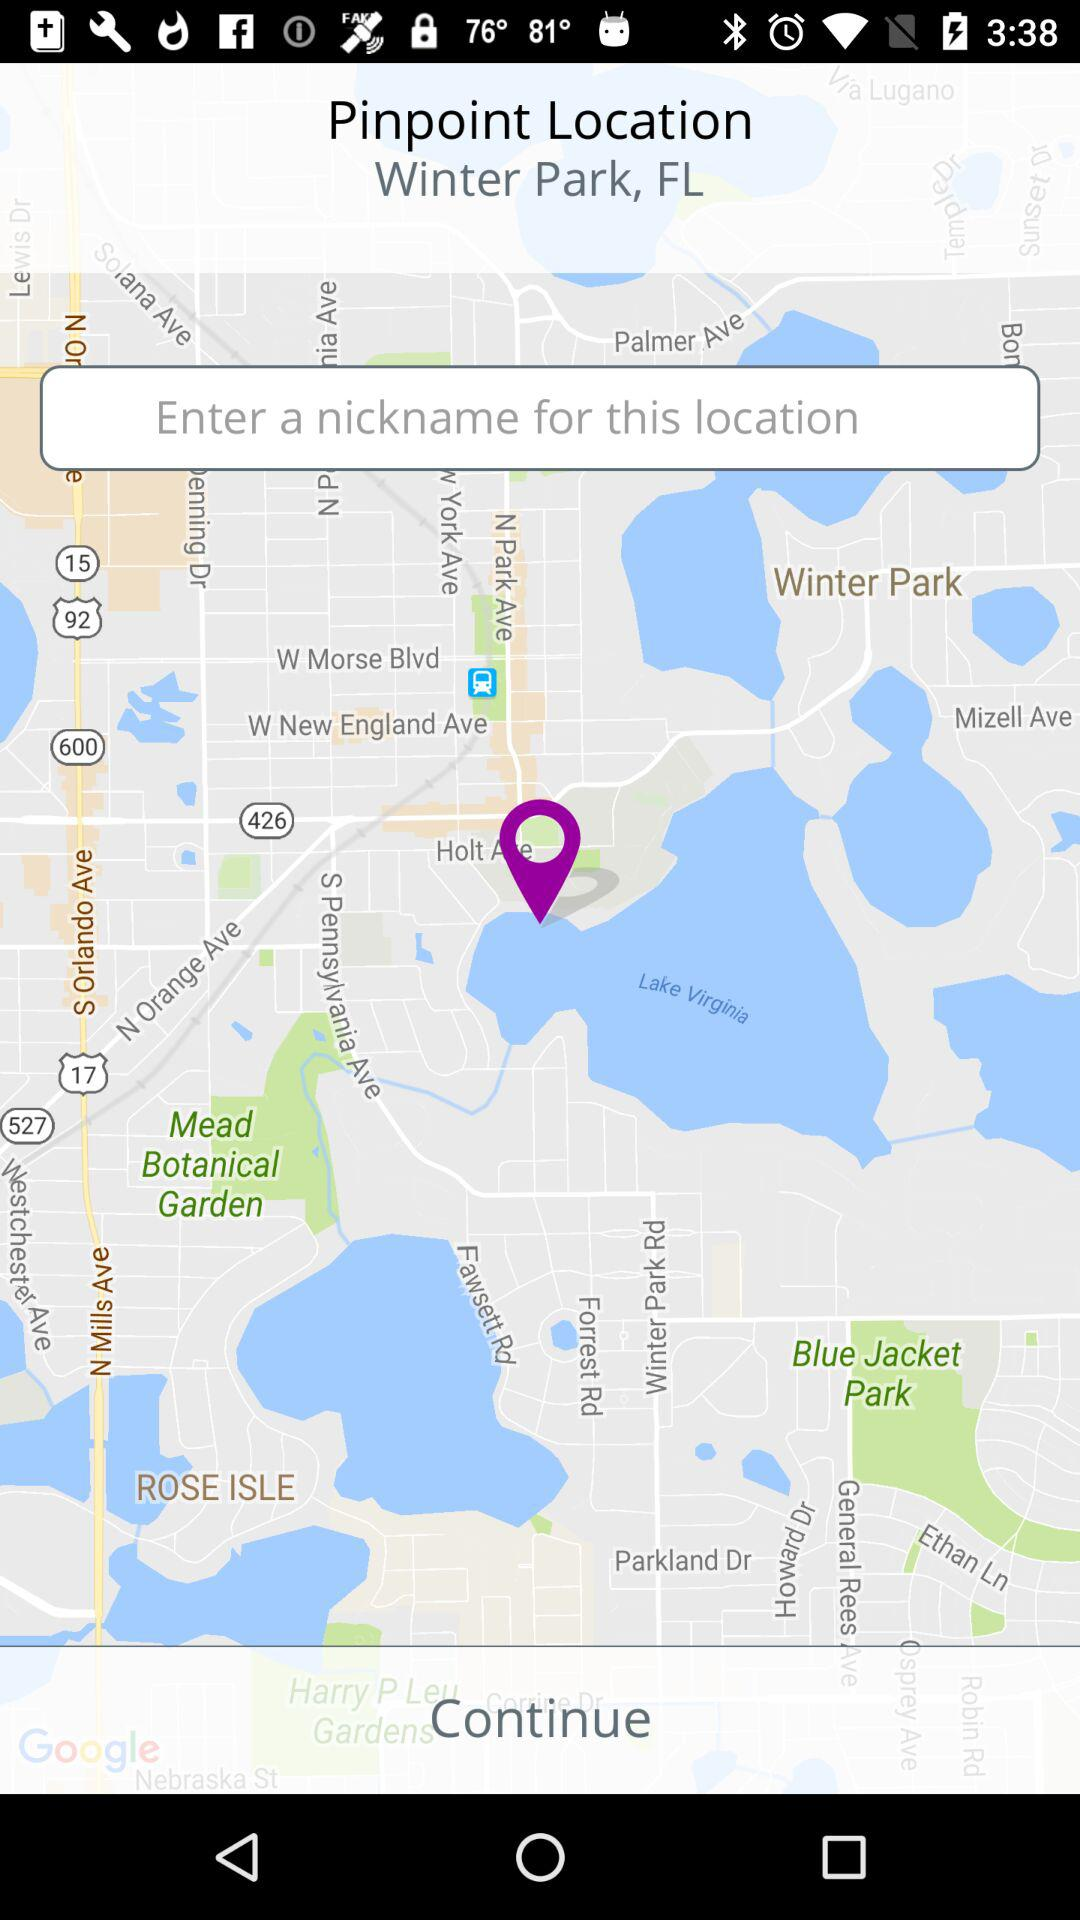What is the location? The location is Winter Park, FL. 